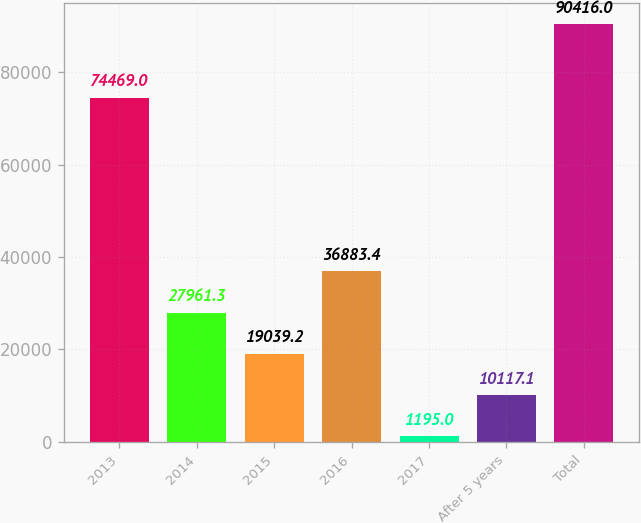Convert chart to OTSL. <chart><loc_0><loc_0><loc_500><loc_500><bar_chart><fcel>2013<fcel>2014<fcel>2015<fcel>2016<fcel>2017<fcel>After 5 years<fcel>Total<nl><fcel>74469<fcel>27961.3<fcel>19039.2<fcel>36883.4<fcel>1195<fcel>10117.1<fcel>90416<nl></chart> 